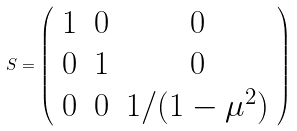<formula> <loc_0><loc_0><loc_500><loc_500>S = \left ( \begin{array} { c c c } 1 & 0 & 0 \\ 0 & 1 & 0 \\ 0 & 0 & 1 / ( 1 - \mu ^ { 2 } ) \end{array} \right )</formula> 